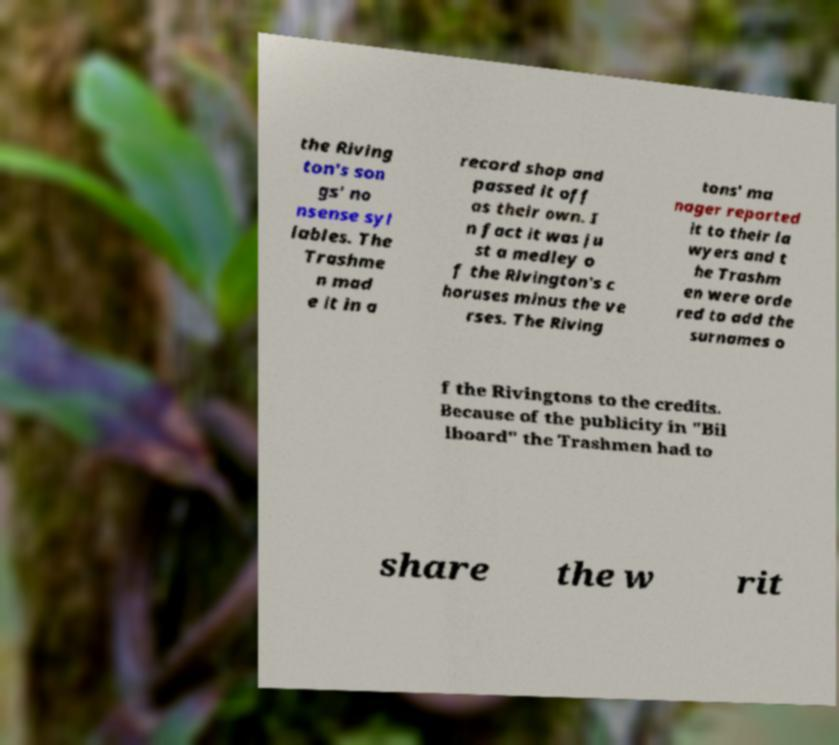Could you extract and type out the text from this image? the Riving ton's son gs' no nsense syl lables. The Trashme n mad e it in a record shop and passed it off as their own. I n fact it was ju st a medley o f the Rivington's c horuses minus the ve rses. The Riving tons' ma nager reported it to their la wyers and t he Trashm en were orde red to add the surnames o f the Rivingtons to the credits. Because of the publicity in "Bil lboard" the Trashmen had to share the w rit 